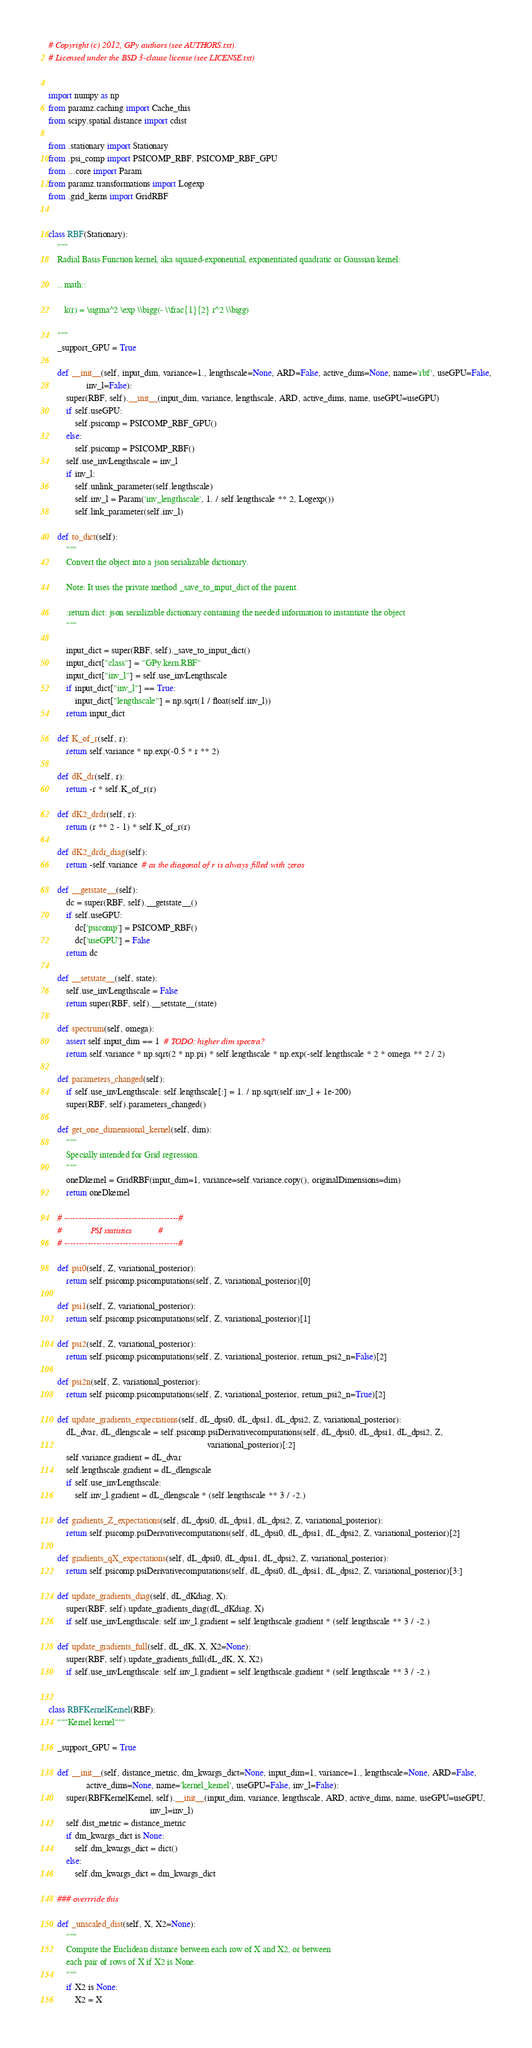Convert code to text. <code><loc_0><loc_0><loc_500><loc_500><_Python_># Copyright (c) 2012, GPy authors (see AUTHORS.txt).
# Licensed under the BSD 3-clause license (see LICENSE.txt)


import numpy as np
from paramz.caching import Cache_this
from scipy.spatial.distance import cdist

from .stationary import Stationary
from .psi_comp import PSICOMP_RBF, PSICOMP_RBF_GPU
from ...core import Param
from paramz.transformations import Logexp
from .grid_kerns import GridRBF


class RBF(Stationary):
    """
    Radial Basis Function kernel, aka squared-exponential, exponentiated quadratic or Gaussian kernel:

    .. math::

       k(r) = \sigma^2 \exp \\bigg(- \\frac{1}{2} r^2 \\bigg)

    """
    _support_GPU = True

    def __init__(self, input_dim, variance=1., lengthscale=None, ARD=False, active_dims=None, name='rbf', useGPU=False,
                 inv_l=False):
        super(RBF, self).__init__(input_dim, variance, lengthscale, ARD, active_dims, name, useGPU=useGPU)
        if self.useGPU:
            self.psicomp = PSICOMP_RBF_GPU()
        else:
            self.psicomp = PSICOMP_RBF()
        self.use_invLengthscale = inv_l
        if inv_l:
            self.unlink_parameter(self.lengthscale)
            self.inv_l = Param('inv_lengthscale', 1. / self.lengthscale ** 2, Logexp())
            self.link_parameter(self.inv_l)

    def to_dict(self):
        """
        Convert the object into a json serializable dictionary.

        Note: It uses the private method _save_to_input_dict of the parent.

        :return dict: json serializable dictionary containing the needed information to instantiate the object
        """

        input_dict = super(RBF, self)._save_to_input_dict()
        input_dict["class"] = "GPy.kern.RBF"
        input_dict["inv_l"] = self.use_invLengthscale
        if input_dict["inv_l"] == True:
            input_dict["lengthscale"] = np.sqrt(1 / float(self.inv_l))
        return input_dict

    def K_of_r(self, r):
        return self.variance * np.exp(-0.5 * r ** 2)

    def dK_dr(self, r):
        return -r * self.K_of_r(r)

    def dK2_drdr(self, r):
        return (r ** 2 - 1) * self.K_of_r(r)

    def dK2_drdr_diag(self):
        return -self.variance  # as the diagonal of r is always filled with zeros

    def __getstate__(self):
        dc = super(RBF, self).__getstate__()
        if self.useGPU:
            dc['psicomp'] = PSICOMP_RBF()
            dc['useGPU'] = False
        return dc

    def __setstate__(self, state):
        self.use_invLengthscale = False
        return super(RBF, self).__setstate__(state)

    def spectrum(self, omega):
        assert self.input_dim == 1  # TODO: higher dim spectra?
        return self.variance * np.sqrt(2 * np.pi) * self.lengthscale * np.exp(-self.lengthscale * 2 * omega ** 2 / 2)

    def parameters_changed(self):
        if self.use_invLengthscale: self.lengthscale[:] = 1. / np.sqrt(self.inv_l + 1e-200)
        super(RBF, self).parameters_changed()

    def get_one_dimensional_kernel(self, dim):
        """
        Specially intended for Grid regression.
        """
        oneDkernel = GridRBF(input_dim=1, variance=self.variance.copy(), originalDimensions=dim)
        return oneDkernel

    # ---------------------------------------#
    #             PSI statistics            #
    # ---------------------------------------#

    def psi0(self, Z, variational_posterior):
        return self.psicomp.psicomputations(self, Z, variational_posterior)[0]

    def psi1(self, Z, variational_posterior):
        return self.psicomp.psicomputations(self, Z, variational_posterior)[1]

    def psi2(self, Z, variational_posterior):
        return self.psicomp.psicomputations(self, Z, variational_posterior, return_psi2_n=False)[2]

    def psi2n(self, Z, variational_posterior):
        return self.psicomp.psicomputations(self, Z, variational_posterior, return_psi2_n=True)[2]

    def update_gradients_expectations(self, dL_dpsi0, dL_dpsi1, dL_dpsi2, Z, variational_posterior):
        dL_dvar, dL_dlengscale = self.psicomp.psiDerivativecomputations(self, dL_dpsi0, dL_dpsi1, dL_dpsi2, Z,
                                                                        variational_posterior)[:2]
        self.variance.gradient = dL_dvar
        self.lengthscale.gradient = dL_dlengscale
        if self.use_invLengthscale:
            self.inv_l.gradient = dL_dlengscale * (self.lengthscale ** 3 / -2.)

    def gradients_Z_expectations(self, dL_dpsi0, dL_dpsi1, dL_dpsi2, Z, variational_posterior):
        return self.psicomp.psiDerivativecomputations(self, dL_dpsi0, dL_dpsi1, dL_dpsi2, Z, variational_posterior)[2]

    def gradients_qX_expectations(self, dL_dpsi0, dL_dpsi1, dL_dpsi2, Z, variational_posterior):
        return self.psicomp.psiDerivativecomputations(self, dL_dpsi0, dL_dpsi1, dL_dpsi2, Z, variational_posterior)[3:]

    def update_gradients_diag(self, dL_dKdiag, X):
        super(RBF, self).update_gradients_diag(dL_dKdiag, X)
        if self.use_invLengthscale: self.inv_l.gradient = self.lengthscale.gradient * (self.lengthscale ** 3 / -2.)

    def update_gradients_full(self, dL_dK, X, X2=None):
        super(RBF, self).update_gradients_full(dL_dK, X, X2)
        if self.use_invLengthscale: self.inv_l.gradient = self.lengthscale.gradient * (self.lengthscale ** 3 / -2.)


class RBFKernelKernel(RBF):
    """Kernel kernel"""

    _support_GPU = True

    def __init__(self, distance_metric, dm_kwargs_dict=None, input_dim=1, variance=1., lengthscale=None, ARD=False,
                 active_dims=None, name='kernel_kernel', useGPU=False, inv_l=False):
        super(RBFKernelKernel, self).__init__(input_dim, variance, lengthscale, ARD, active_dims, name, useGPU=useGPU,
                                              inv_l=inv_l)
        self.dist_metric = distance_metric
        if dm_kwargs_dict is None:
            self.dm_kwargs_dict = dict()
        else:
            self.dm_kwargs_dict = dm_kwargs_dict

    ### overrride this

    def _unscaled_dist(self, X, X2=None):
        """
        Compute the Euclidean distance between each row of X and X2, or between
        each pair of rows of X if X2 is None.
        """
        if X2 is None:
            X2 = X</code> 